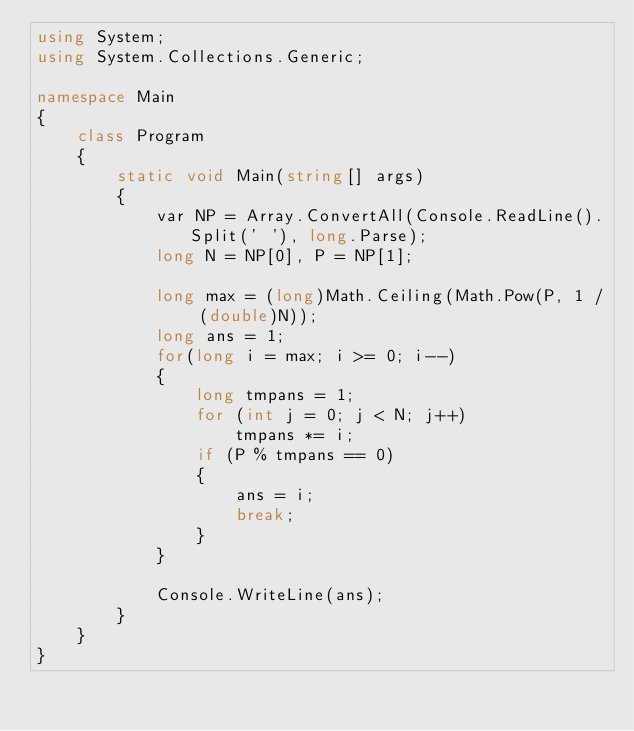Convert code to text. <code><loc_0><loc_0><loc_500><loc_500><_C#_>using System;
using System.Collections.Generic;

namespace Main
{
    class Program
    {
        static void Main(string[] args)
        {
            var NP = Array.ConvertAll(Console.ReadLine().Split(' '), long.Parse);
            long N = NP[0], P = NP[1];

            long max = (long)Math.Ceiling(Math.Pow(P, 1 / (double)N));
            long ans = 1;
            for(long i = max; i >= 0; i--)
            {
                long tmpans = 1;
                for (int j = 0; j < N; j++)
                    tmpans *= i;
                if (P % tmpans == 0)
                {
                    ans = i;
                    break;
                }
            }

            Console.WriteLine(ans);
        }
    }
}
</code> 